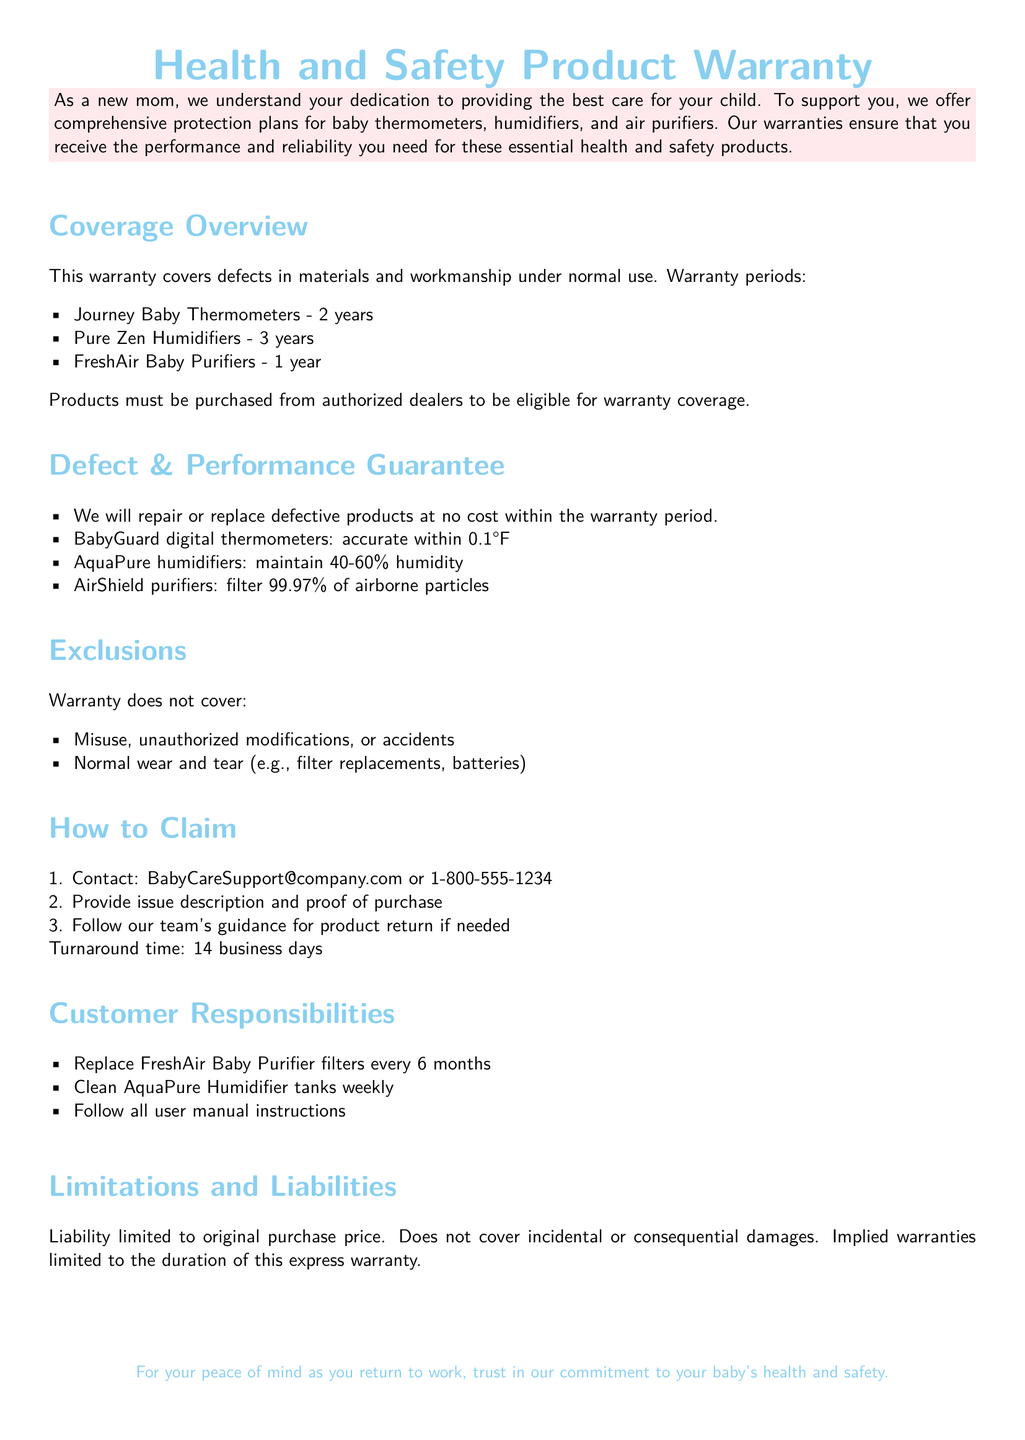what is the warranty period for Journey Baby Thermometers? The warranty period is specified under Coverage Overview as 2 years.
Answer: 2 years what is the maximum humidity maintained by AquaPure humidifiers? The performance guarantees mention that AquaPure humidifiers maintain a humidity level of 40-60%.
Answer: 40-60% what is covered under the defect guarantee? The document states that the company will repair or replace defective products at no cost within the warranty period.
Answer: Repair or replace defective products who should you contact to claim the warranty? The How to Claim section lists the contact email and phone number as BabyCareSupport@company.com or 1-800-555-1234.
Answer: BabyCareSupport@company.com or 1-800-555-1234 how often should FreshAir Baby Purifier filters be replaced? The Customer Responsibilities section specifies the replacement frequency for filters is every 6 months.
Answer: Every 6 months what types of damages are not covered by the warranty? The Exclusions section outlines that it does not cover incidental or consequential damages.
Answer: Incidental or consequential damages what is the accuracy range of BabyGuard digital thermometers? The document states that BabyGuard digital thermometers are accurate within 0.1°F.
Answer: 0.1°F what is the turnaround time for warranty claims? The How to Claim section indicates a turnaround time of 14 business days.
Answer: 14 business days 